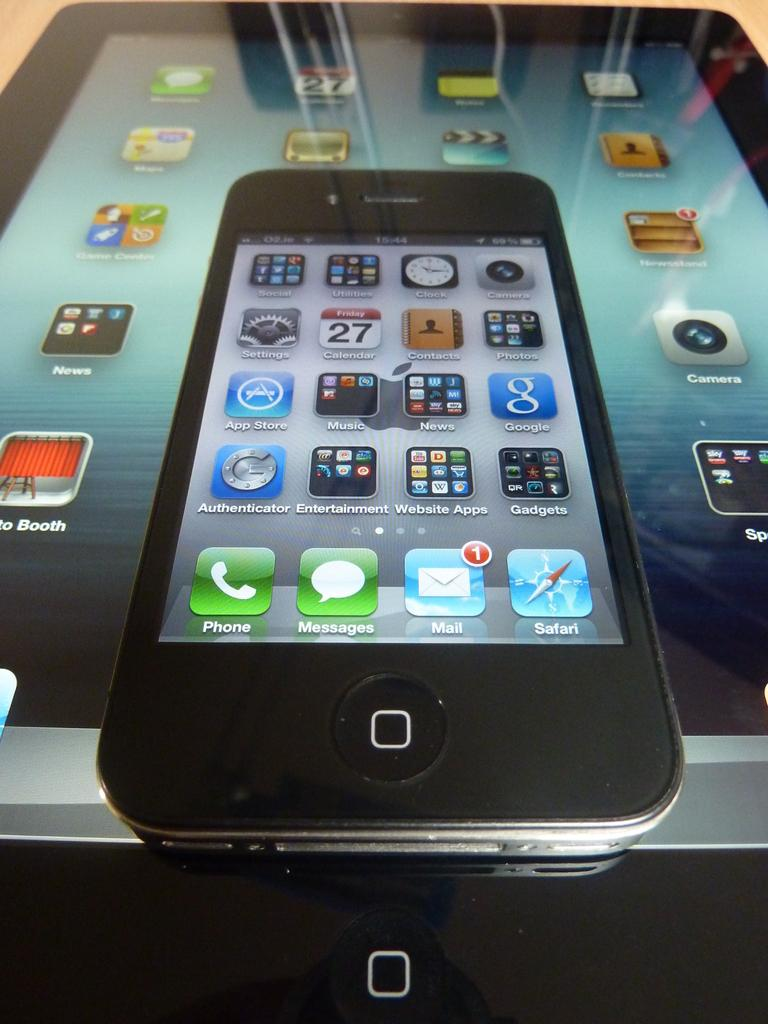<image>
Provide a brief description of the given image. A phone that includes an app called Authenticator sits on top of a tablet. 